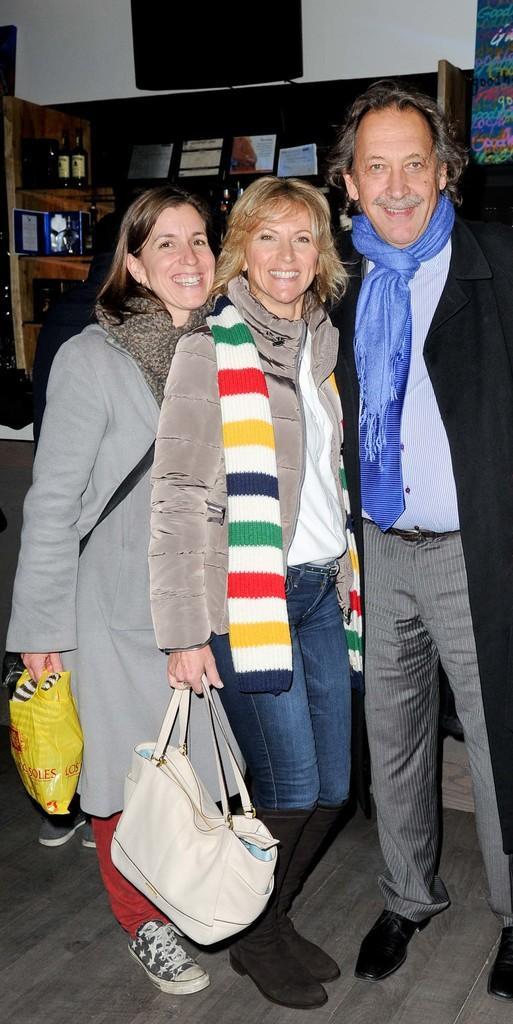Please provide a concise description of this image. In this picture we can see one men and two woman holding bags and plastic covers they are smiling and in background we can see racks with books, bottles, papers and wall. 